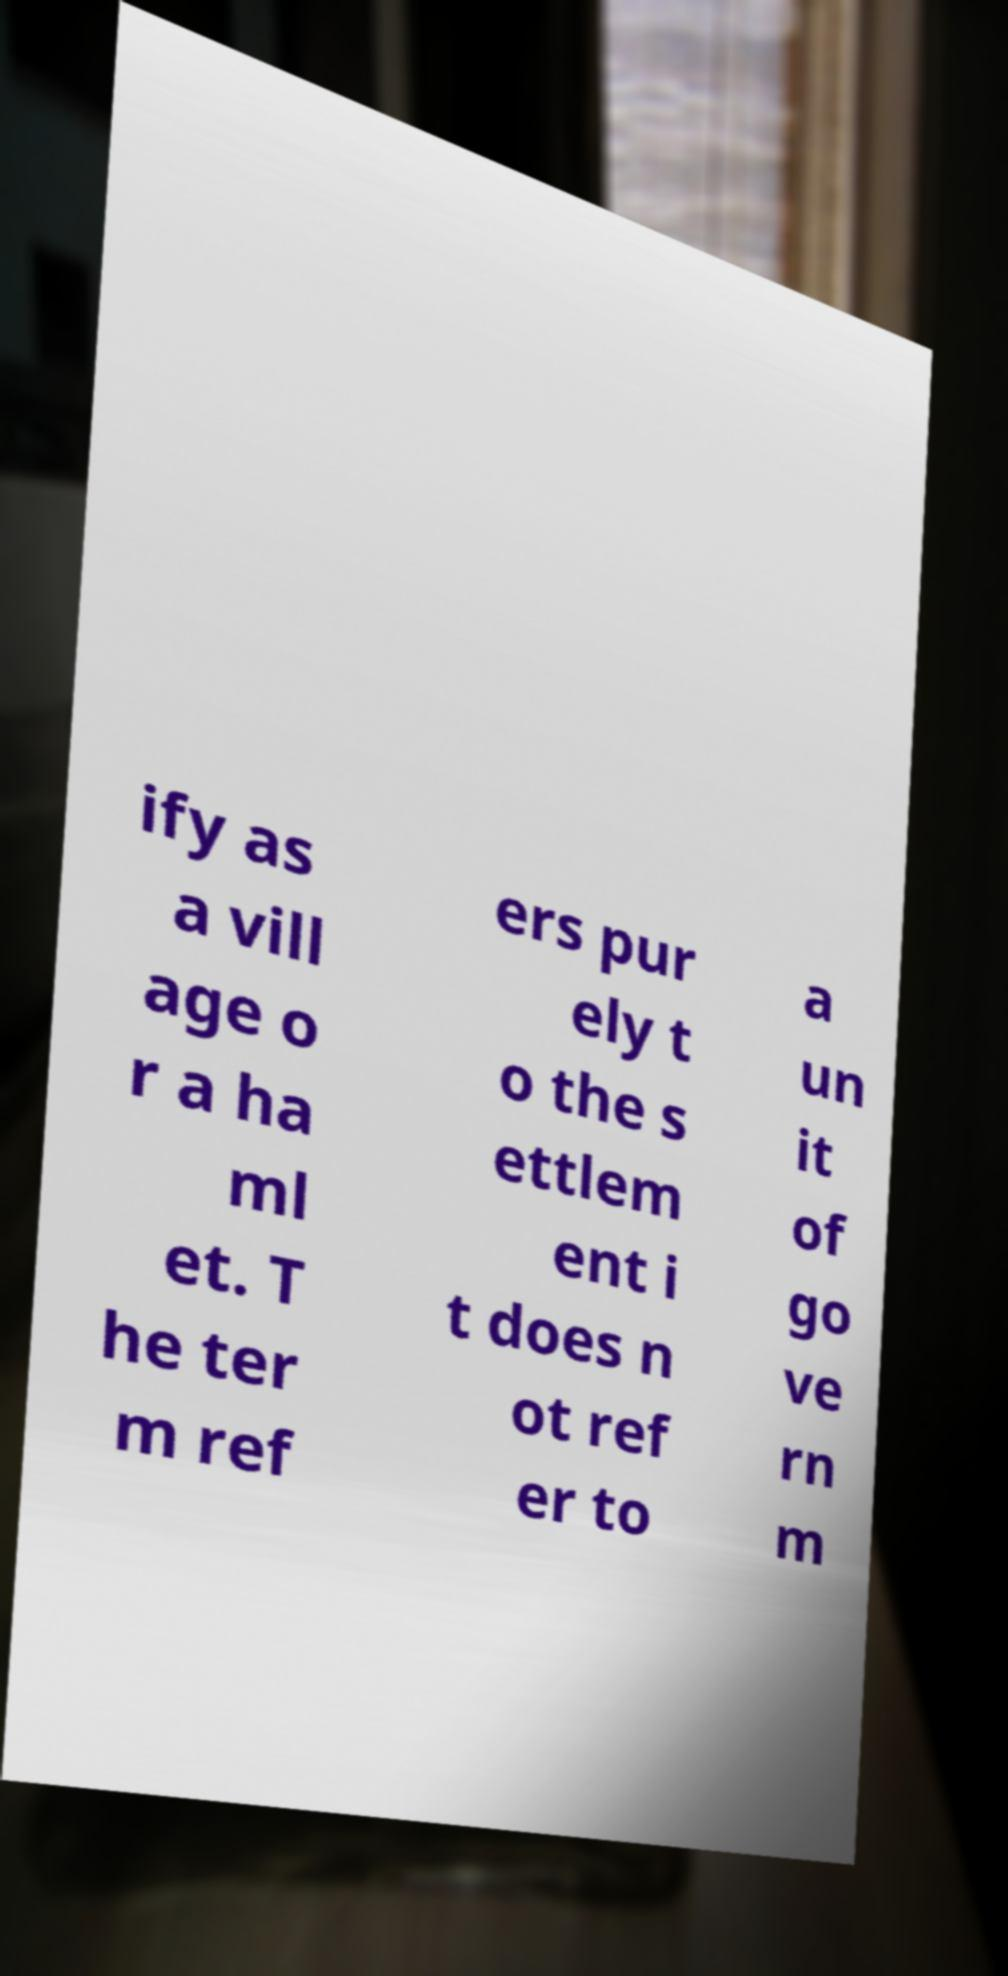I need the written content from this picture converted into text. Can you do that? ify as a vill age o r a ha ml et. T he ter m ref ers pur ely t o the s ettlem ent i t does n ot ref er to a un it of go ve rn m 